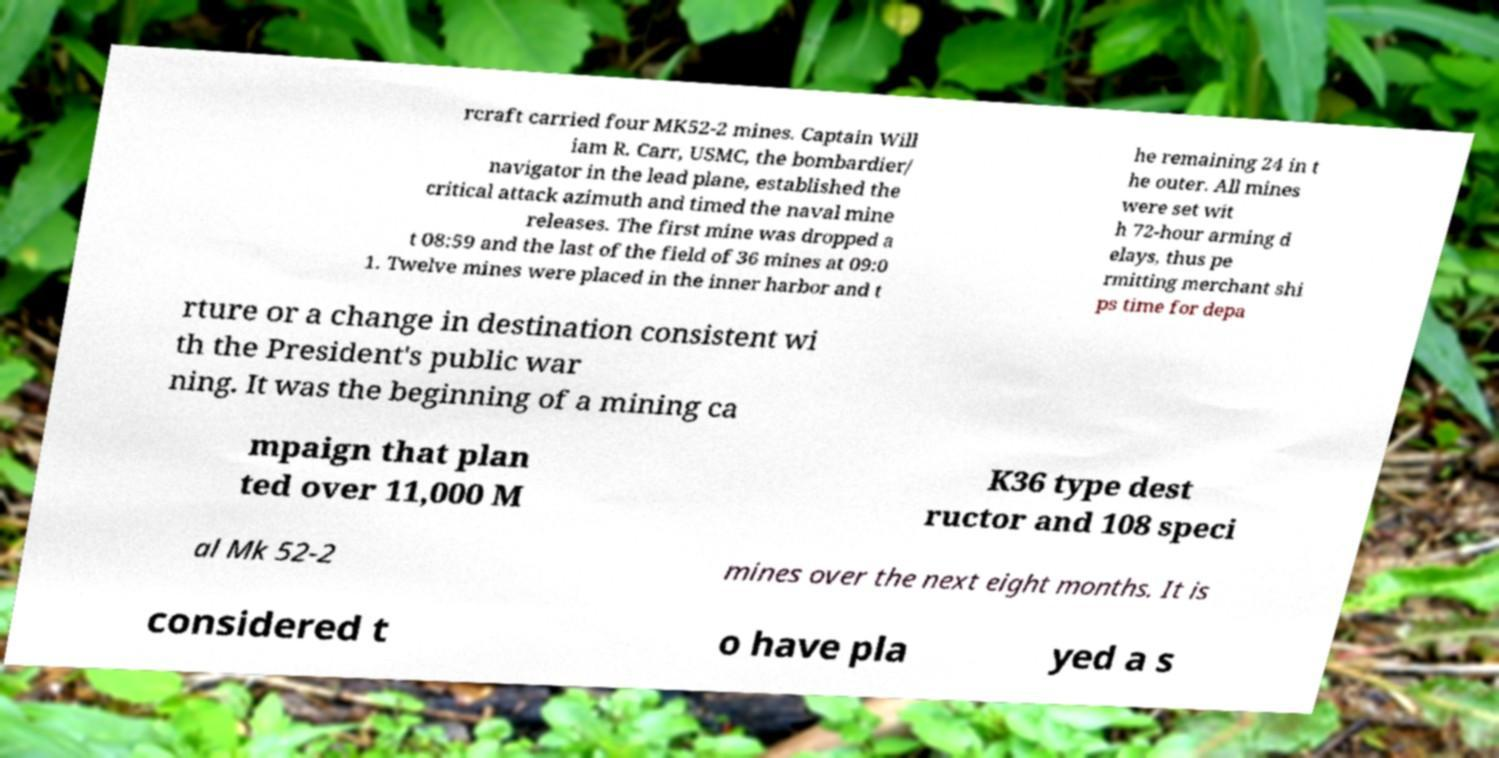I need the written content from this picture converted into text. Can you do that? rcraft carried four MK52-2 mines. Captain Will iam R. Carr, USMC, the bombardier/ navigator in the lead plane, established the critical attack azimuth and timed the naval mine releases. The first mine was dropped a t 08:59 and the last of the field of 36 mines at 09:0 1. Twelve mines were placed in the inner harbor and t he remaining 24 in t he outer. All mines were set wit h 72-hour arming d elays, thus pe rmitting merchant shi ps time for depa rture or a change in destination consistent wi th the President's public war ning. It was the beginning of a mining ca mpaign that plan ted over 11,000 M K36 type dest ructor and 108 speci al Mk 52-2 mines over the next eight months. It is considered t o have pla yed a s 